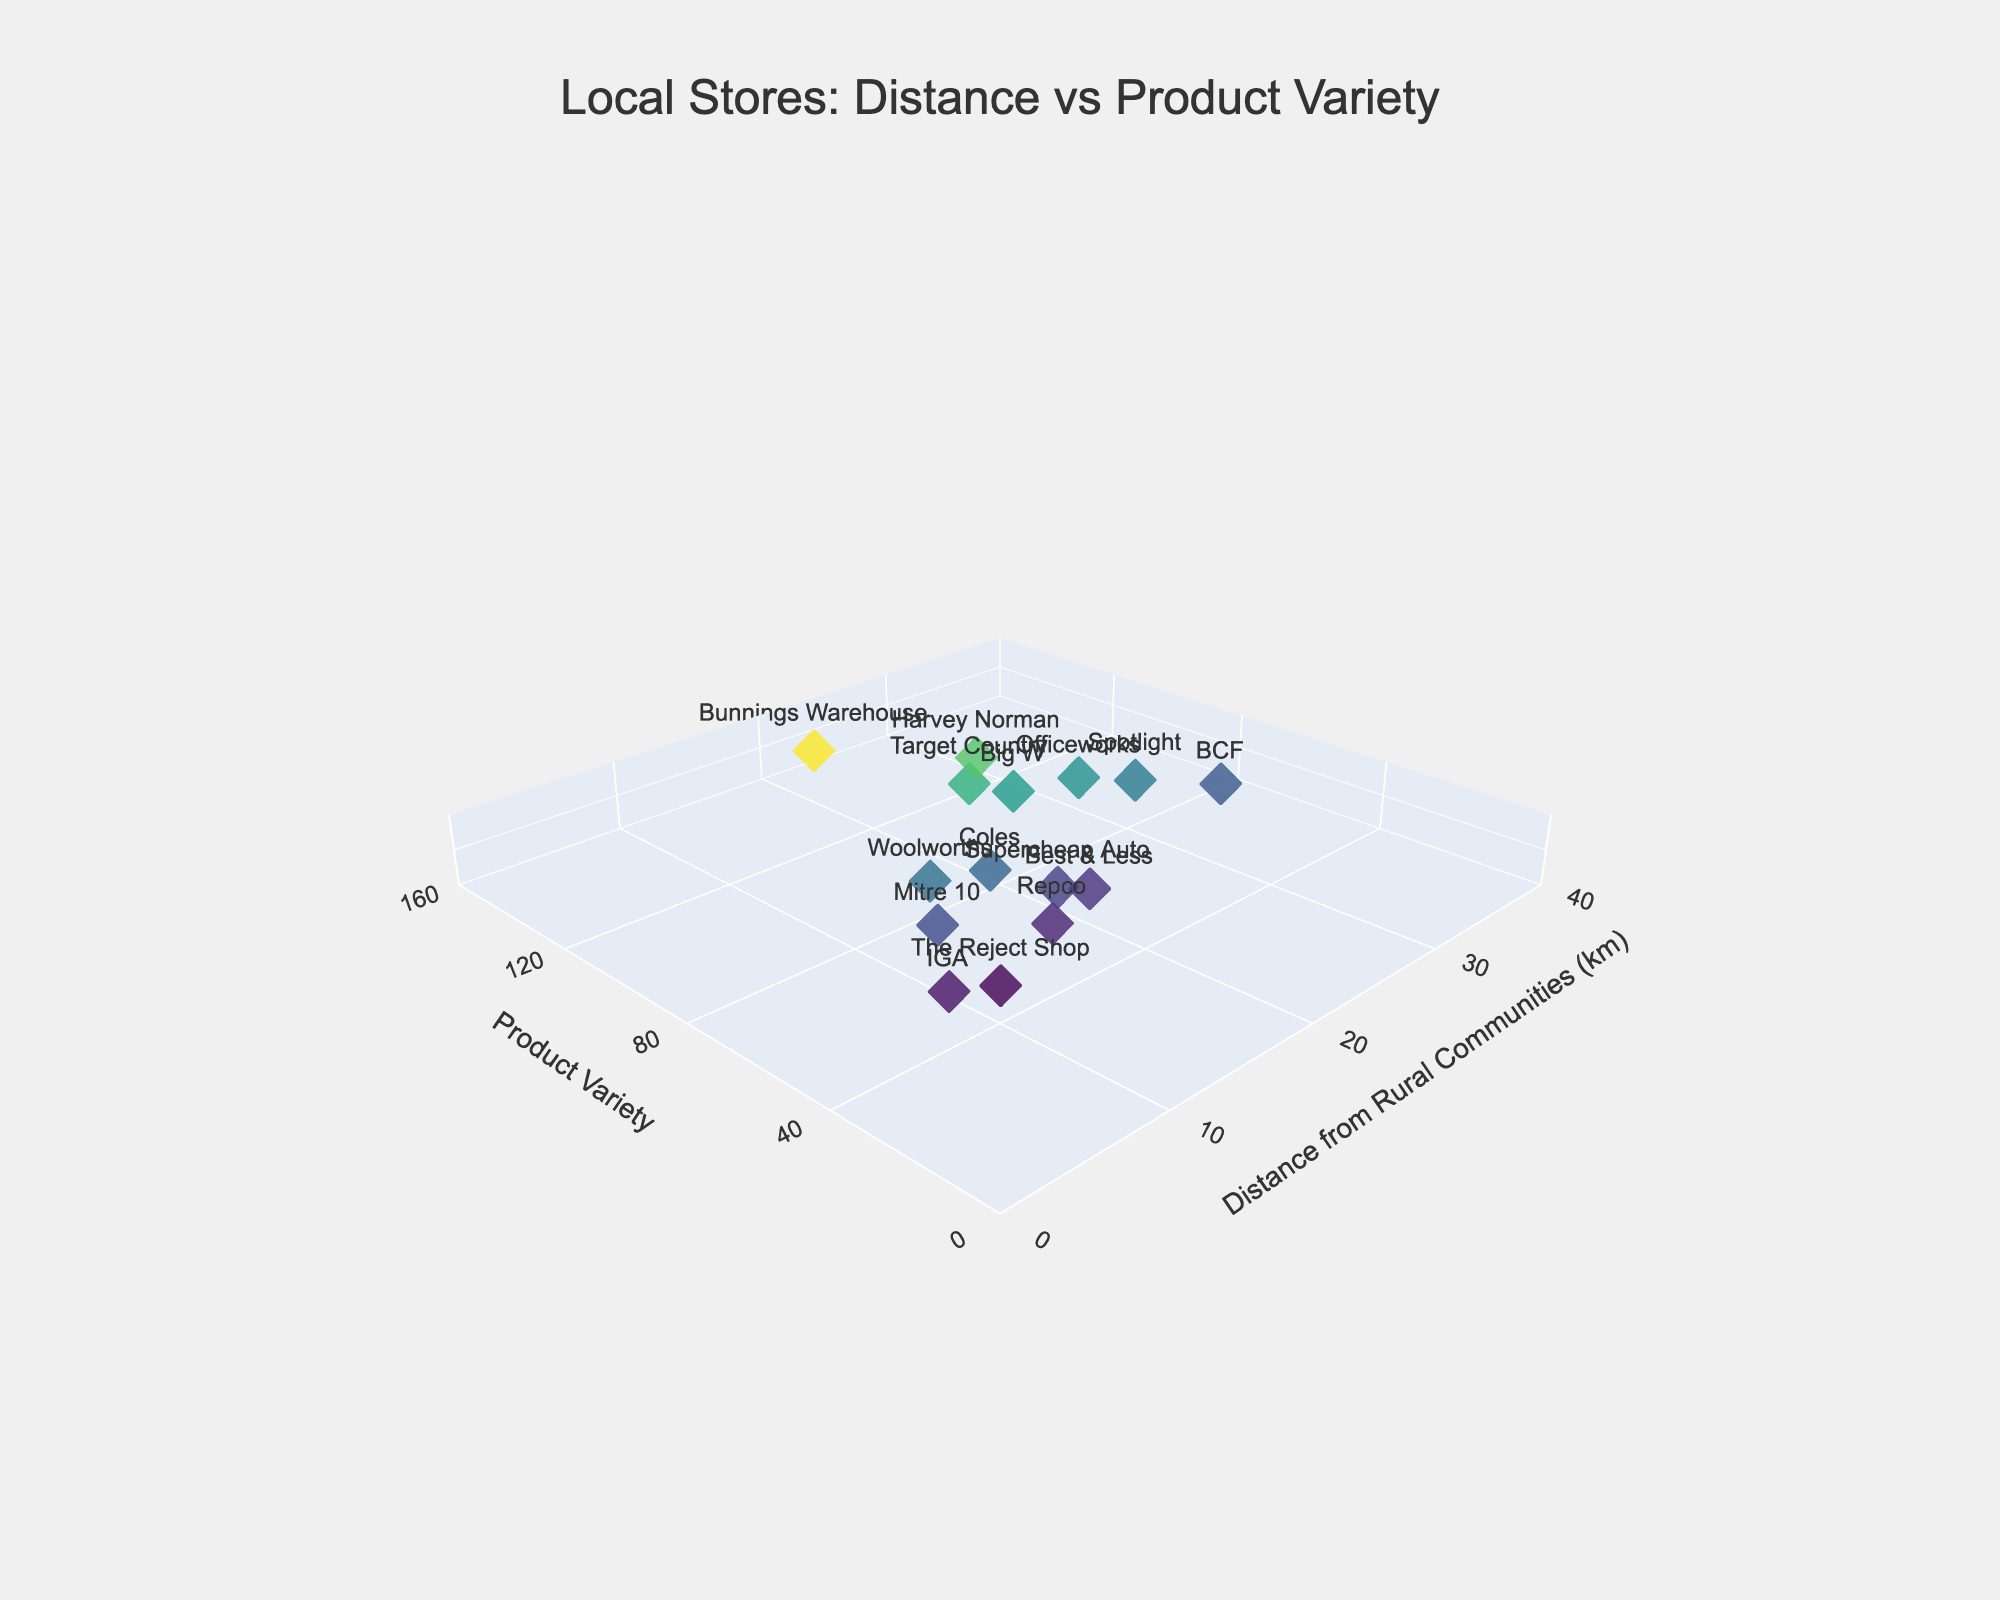What is the title of the figure? The title of the figure can be seen at the top of the plot, centered.
Answer: "Local Stores: Distance vs Product Variety" What store is the furthest from rural communities? Identify the store with the highest distance value on the x-axis.
Answer: BCF Which store has the highest product variety? Look for the store that reaches the maximum value on the y-axis.
Answer: Bunnings Warehouse How many stores are located within 20 km from rural communities? Count the number of stores with distances less than or equal to 20 km from the x-axis labels.
Answer: 7 (Woolworths, IGA, Mitre 10, The Reject Shop, Repco, Supercheap Auto, Best & Less) What's the average product variety for stores located within 10 km from rural communities? Identify the stores within a 10 km distance, sum their product variety values, and divide by the number of these stores. The stores are IGA (45) and The Reject Shop (40), so (45+40)/2 = 42.5.
Answer: 42.5 Which store has a distance of 25 km from rural communities and what is its product variety? Look for a store at the 25 km mark on the x-axis and note its product variety from the y-axis value.
Answer: Target Country, 110 Compare Woolworths and Coles in terms of distance and product variety. Which has more product variety and which is closer? Find Woolworths and Coles on the plot and compare their distances and product variety values. Woolworths: Distance 15 km, Product Variety 80; Coles: Distance 18 km, Product Variety 75. Woolworths is closer, and Woolworths also has more product variety.
Answer: Woolworths is closer and has more product variety What's the average distance of stores with a product variety over 100? Identify stores with a product variety over 100, sum their distances, and divide by the number of these stores: Bunnings Warehouse (150, 22 km), Target Country (110, 25 km), Harvey Norman (120, 28 km), Big W (100, 26 km); average distance = (22+25+28+26)/4 = 25.25 km.
Answer: 25.25 km How does the product variety of Target Country compare to Spotlight? Locate Target Country and Spotlight on the plot, and note their respective product variety values (y-axis). Target Country: 110, Spotlight: 85. Compare these values.
Answer: Target Country has more product variety than Spotlight Which stores are located more than 30 km away, and what are their product varieties? Identify stores with distances greater than 30 km and note their product variety values. Officeworks (95), BCF (70), and Spotlight (85).
Answer: Officeworks (95), BCF (70), Spotlight (85) Identify the store with the smallest product variety and its distance from rural communities. Find the store with the smallest value on the y-axis and note its corresponding x-axis value. The Reject Shop: 40, Distance 10 km.
Answer: The Reject Shop, 10 km 